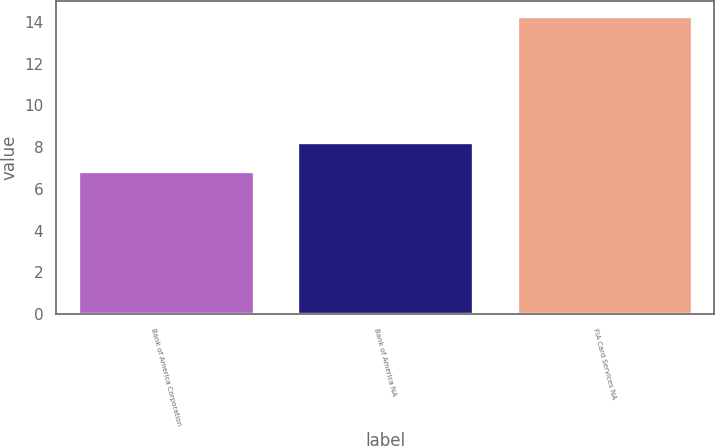Convert chart. <chart><loc_0><loc_0><loc_500><loc_500><bar_chart><fcel>Bank of America Corporation<fcel>Bank of America NA<fcel>FIA Card Services NA<nl><fcel>6.87<fcel>8.23<fcel>14.29<nl></chart> 